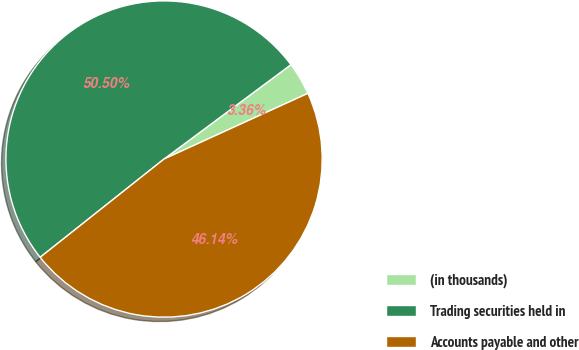Convert chart to OTSL. <chart><loc_0><loc_0><loc_500><loc_500><pie_chart><fcel>(in thousands)<fcel>Trading securities held in<fcel>Accounts payable and other<nl><fcel>3.36%<fcel>50.5%<fcel>46.14%<nl></chart> 